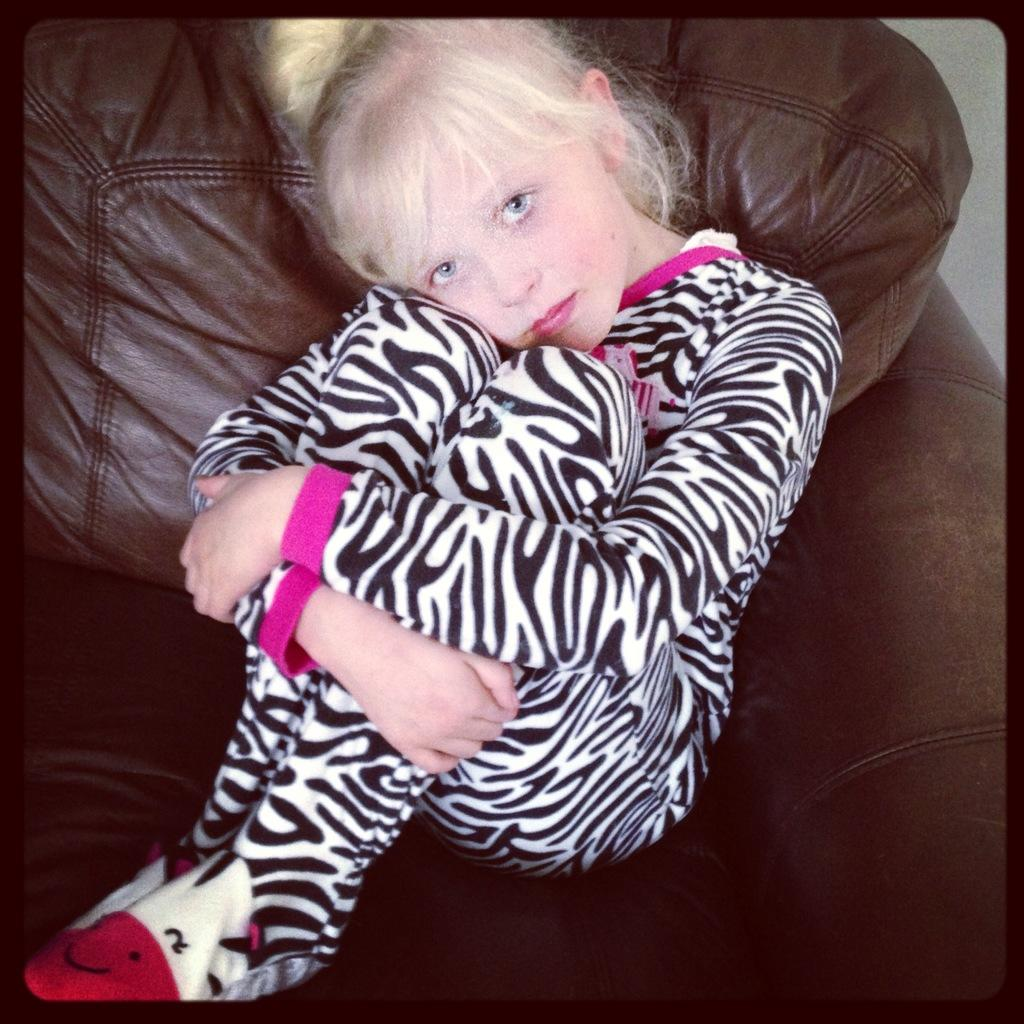Who is the main subject in the image? There is a girl in the image. What is the girl doing in the image? The girl is sitting on a couch. What type of jeans is the girl wearing in the image? The facts provided do not mention the girl's clothing, so we cannot determine if she is wearing jeans or any other type of clothing. 